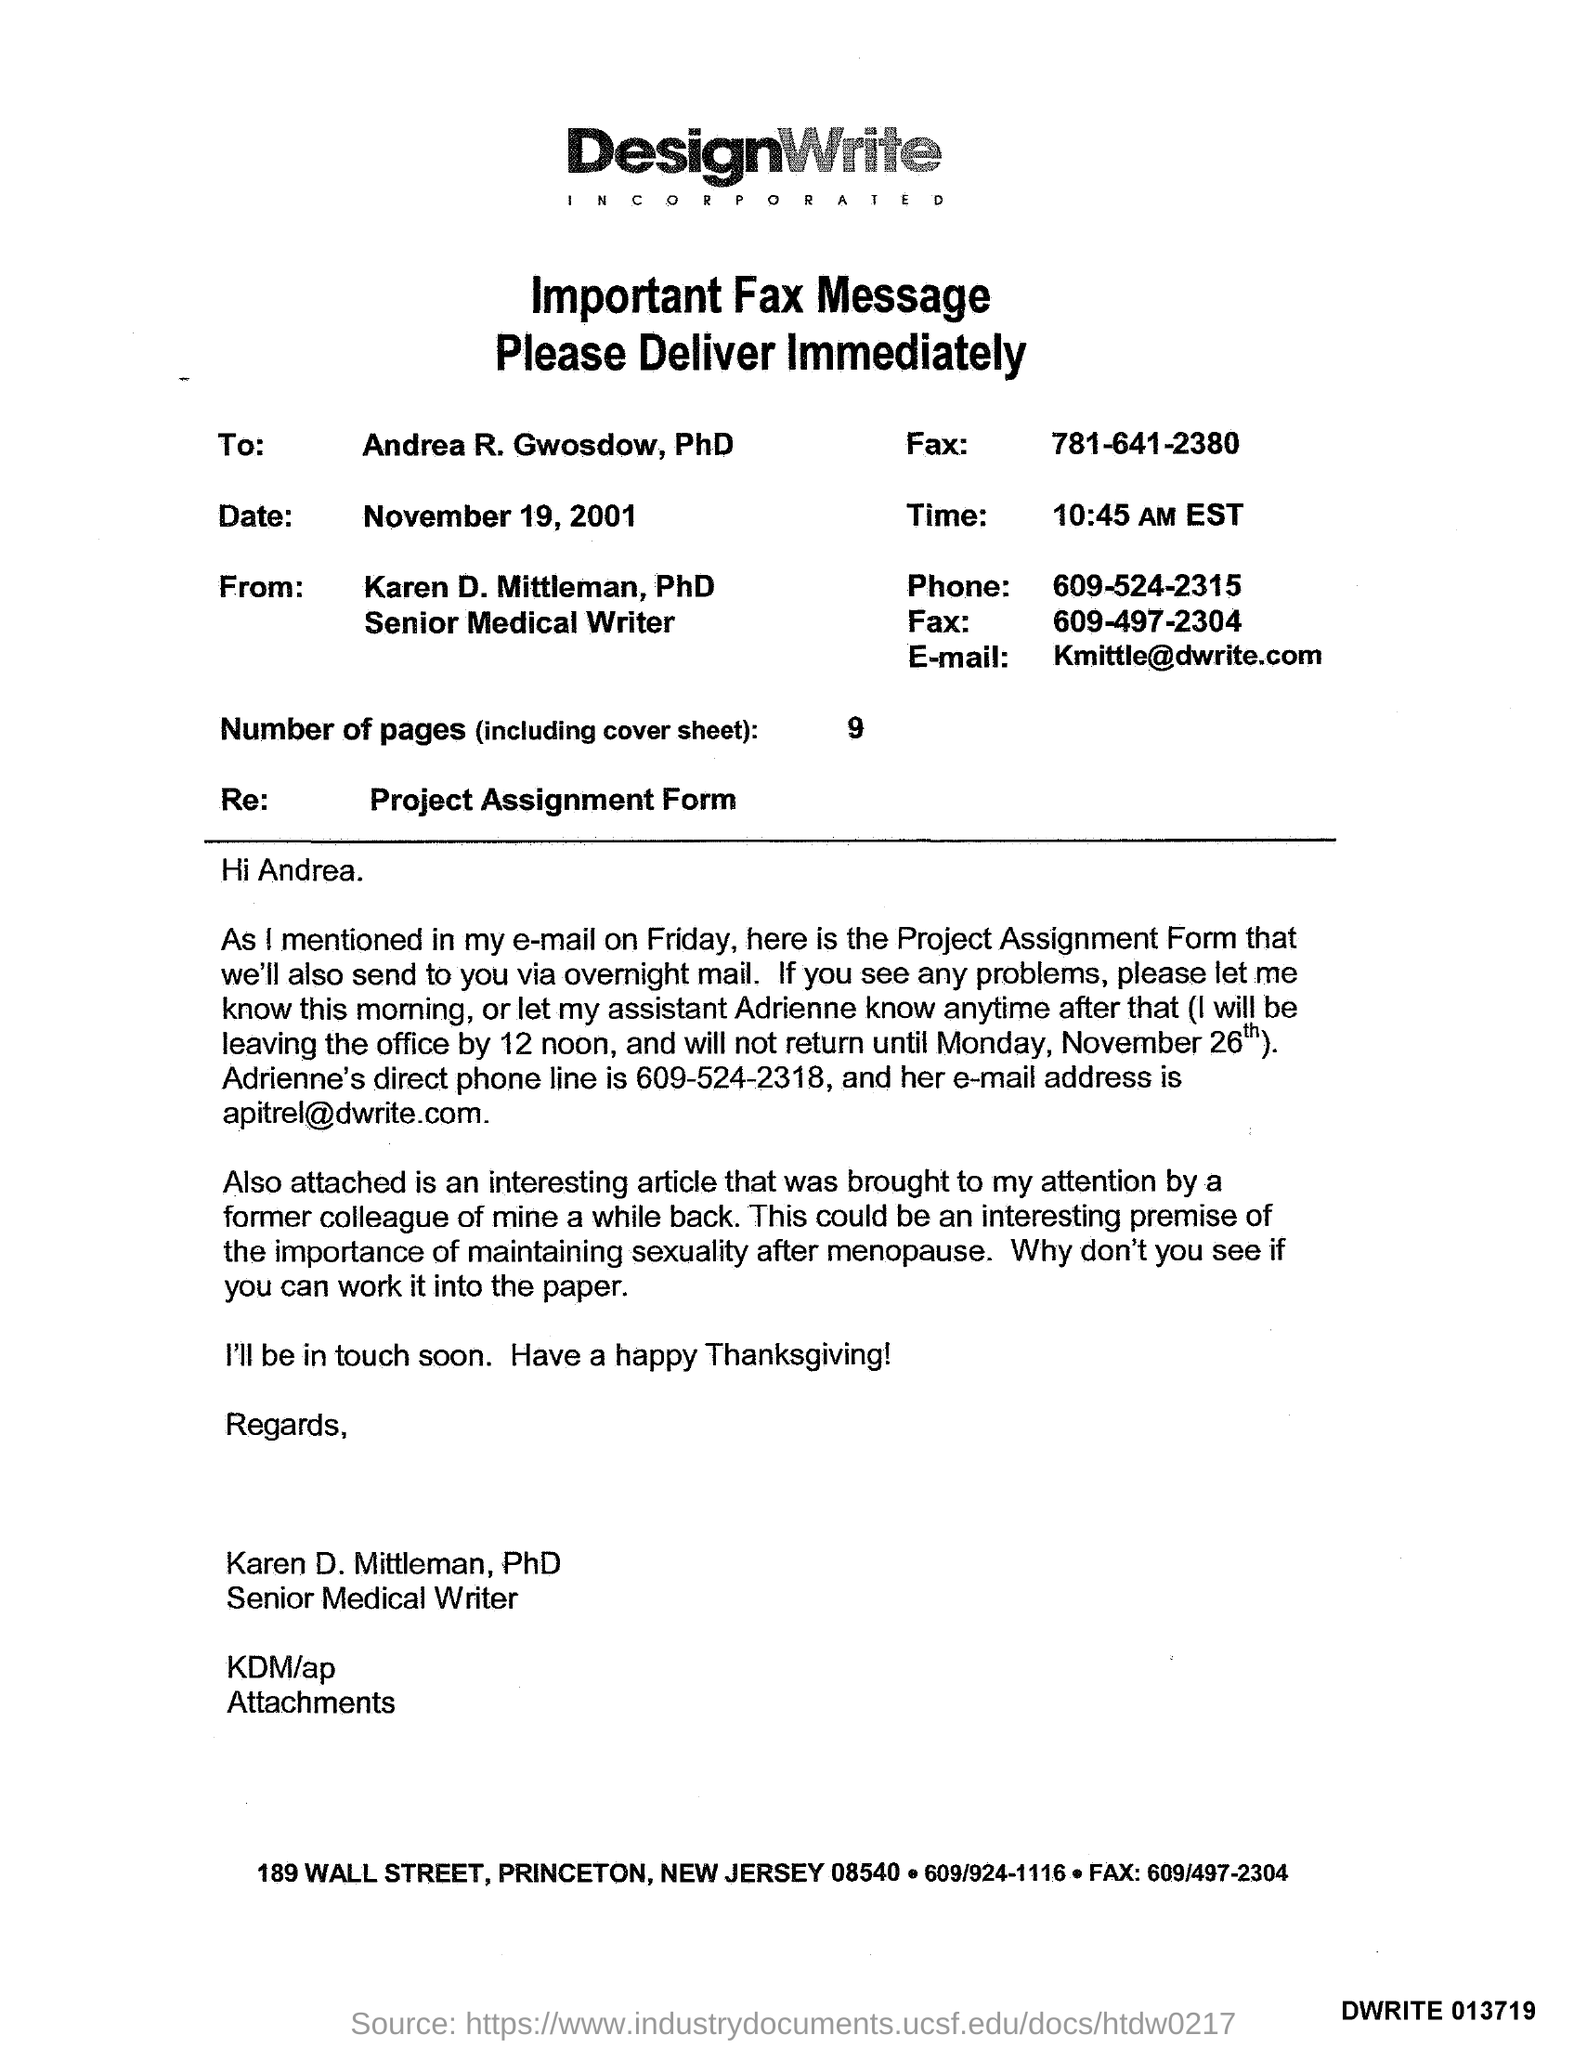What is the time?
Give a very brief answer. 10:45 AM EST. What is the number of pages?
Make the answer very short. 9. What is the E- mail address?
Give a very brief answer. Kmittle@dwrite.com. What is the phone number?
Make the answer very short. 609-524-2315. 